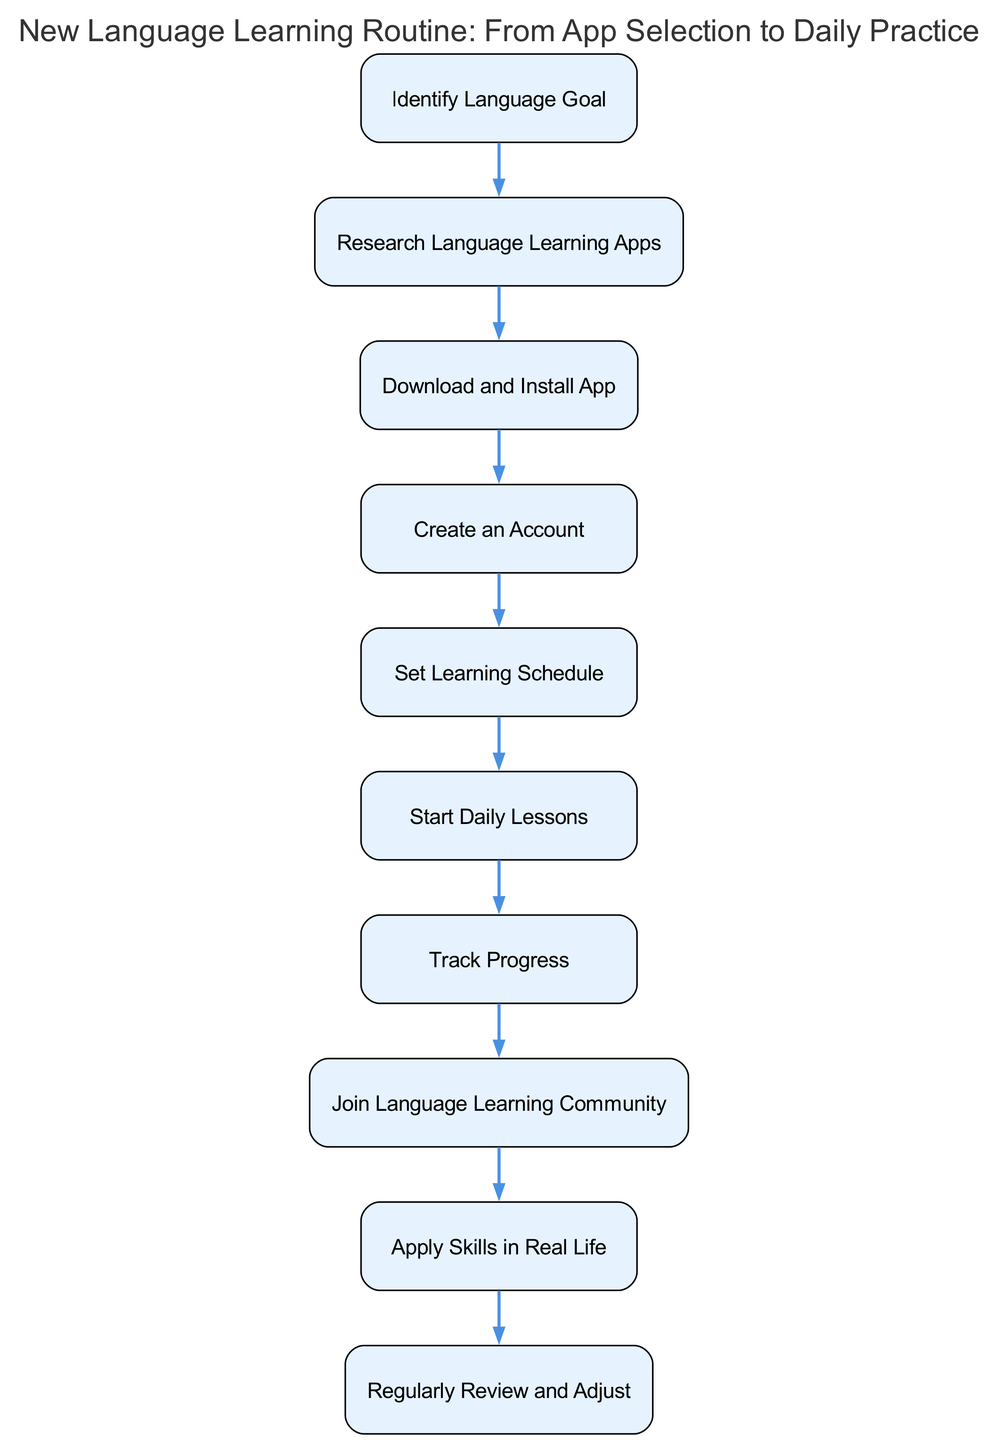What is the first step in the routine? The first step in the routine is to "Identify Language Goal." This is directly stated as the first node in the flow chart.
Answer: Identify Language Goal How many steps are in the language learning routine? There are ten steps in total, as each step is represented as a node in the flow chart.
Answer: 10 Which step follows "Download and Install App"? "Create an Account" is the step that follows "Download and Install App," indicated by a directed edge connecting these two nodes.
Answer: Create an Account What is the last step in this routine? The last step is "Regularly Review and Adjust," as it is the final node in the sequence.
Answer: Regularly Review and Adjust What two steps are directly connected to "Set Learning Schedule"? "Create an Account" precedes it, and "Start Daily Lessons" follows it, indicating these steps are directly linked by the flow between them.
Answer: Create an Account, Start Daily Lessons Which step involves community participation? The step that involves community participation is "Join Language Learning Community," as stated in that node.
Answer: Join Language Learning Community How does one monitor progress in the routine? Progress is monitored through the "Track Progress" step, which emphasizes the use of app features like streaks and leaderboards to keep track of learning.
Answer: Track Progress What step requires practical application of language skills? The step that requires practical application is "Apply Skills in Real Life," as it focuses on utilizing learned skills in meaningful situations.
Answer: Apply Skills in Real Life What prerequisite must be completed before starting daily lessons? The prerequisite for starting daily lessons is setting a "Set Learning Schedule," which ensures that practice time is allocated before lessons begin.
Answer: Set Learning Schedule 